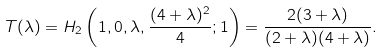Convert formula to latex. <formula><loc_0><loc_0><loc_500><loc_500>T ( \lambda ) = H _ { 2 } \left ( 1 , 0 , \lambda , \frac { ( 4 + \lambda ) ^ { 2 } } { 4 } ; 1 \right ) = \frac { 2 ( 3 + \lambda ) } { ( 2 + \lambda ) ( 4 + \lambda ) } .</formula> 